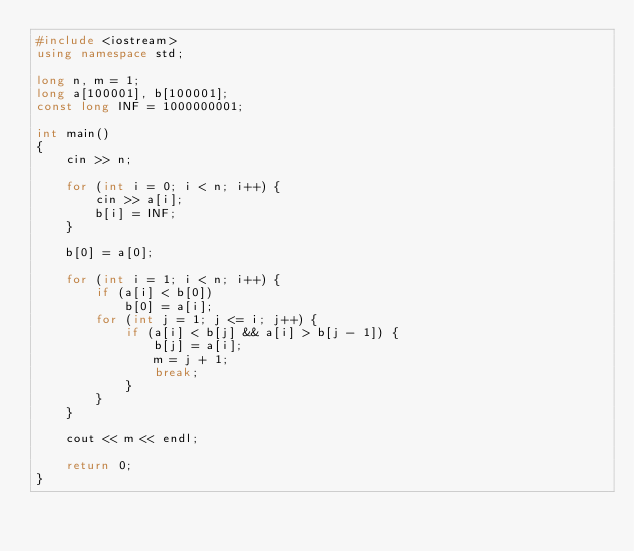Convert code to text. <code><loc_0><loc_0><loc_500><loc_500><_C++_>#include <iostream>
using namespace std;

long n, m = 1;
long a[100001], b[100001];
const long INF = 1000000001;

int main()
{
	cin >> n;

	for (int i = 0; i < n; i++) {
		cin >> a[i];
		b[i] = INF;
	}

	b[0] = a[0];

	for (int i = 1; i < n; i++) {
		if (a[i] < b[0])
			b[0] = a[i];
		for (int j = 1; j <= i; j++) {
			if (a[i] < b[j] && a[i] > b[j - 1]) {
				b[j] = a[i];
				m = j + 1;
				break;
			}
		}
	}

	cout << m << endl;

	return 0;
}
</code> 